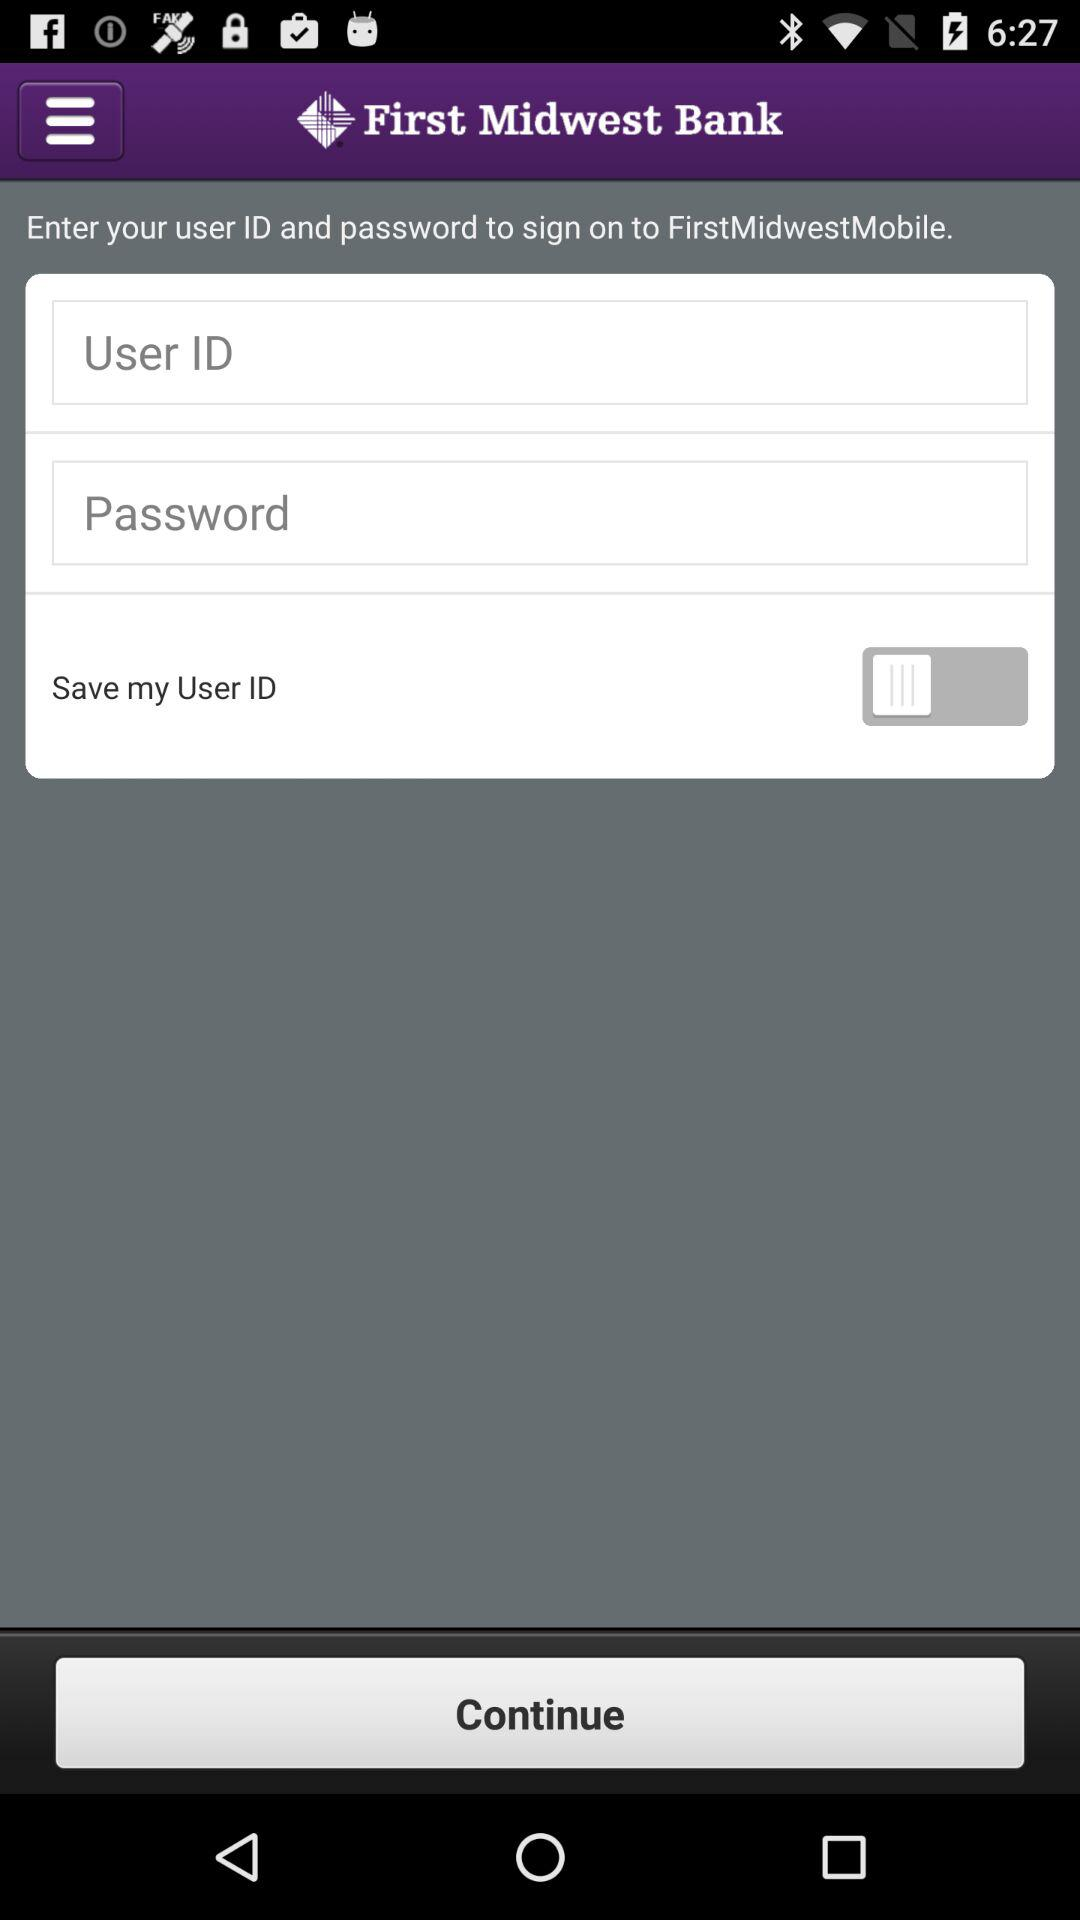How many fields are there for entering information?
Answer the question using a single word or phrase. 2 